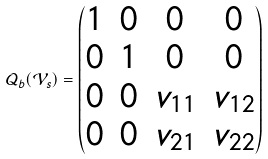<formula> <loc_0><loc_0><loc_500><loc_500>\mathcal { Q } _ { b } ( \mathcal { V } _ { s } ) = \begin{pmatrix} 1 & 0 & 0 & 0 \\ 0 & 1 & 0 & 0 \\ 0 & 0 & v _ { 1 1 } & v _ { 1 2 } \\ 0 & 0 & v _ { 2 1 } & v _ { 2 2 } \end{pmatrix}</formula> 